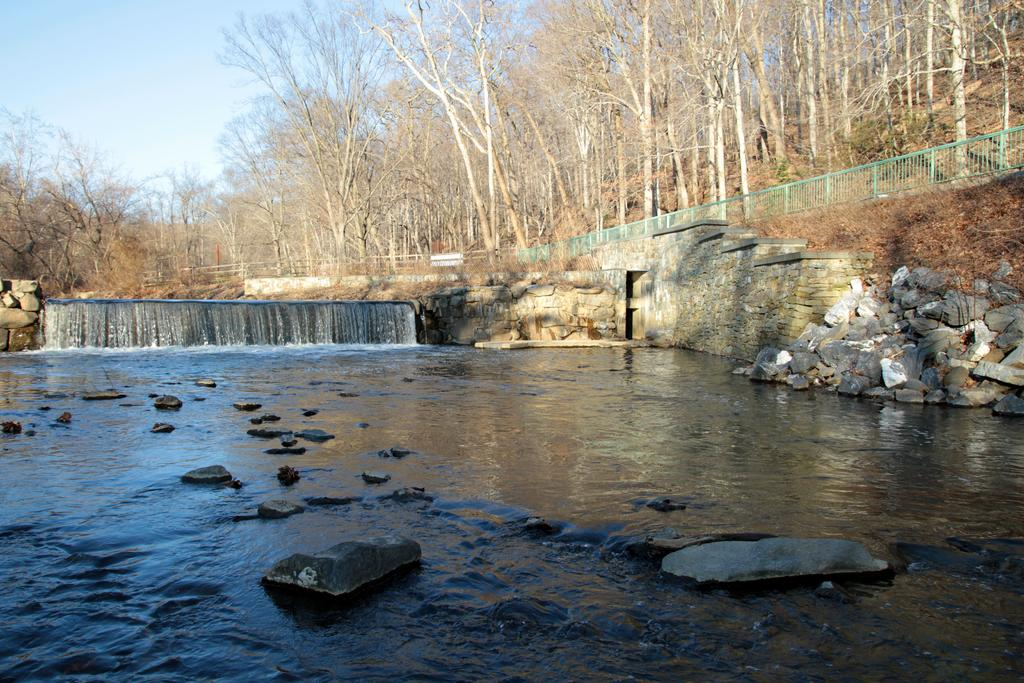What can be seen in the sky in the image? The sky is visible in the image. What type of natural features are present in the image? There are trees, hills, and a waterfall in the image. What is used for cooking in the image? There is a grill in the image. What type of structures are present in the image? There are walls in the image. What is the source of water in the image? Running water is present in the image, coming from the waterfall. What type of material is visible in the image? Stones are visible in the image. What type of shelf can be seen in the image? There is no shelf present in the image. What is the acoustics like in the image? The image does not provide information about the acoustics, as it focuses on visual elements such as the sky, trees, hills, waterfall, grill, walls, running water, and stones. 